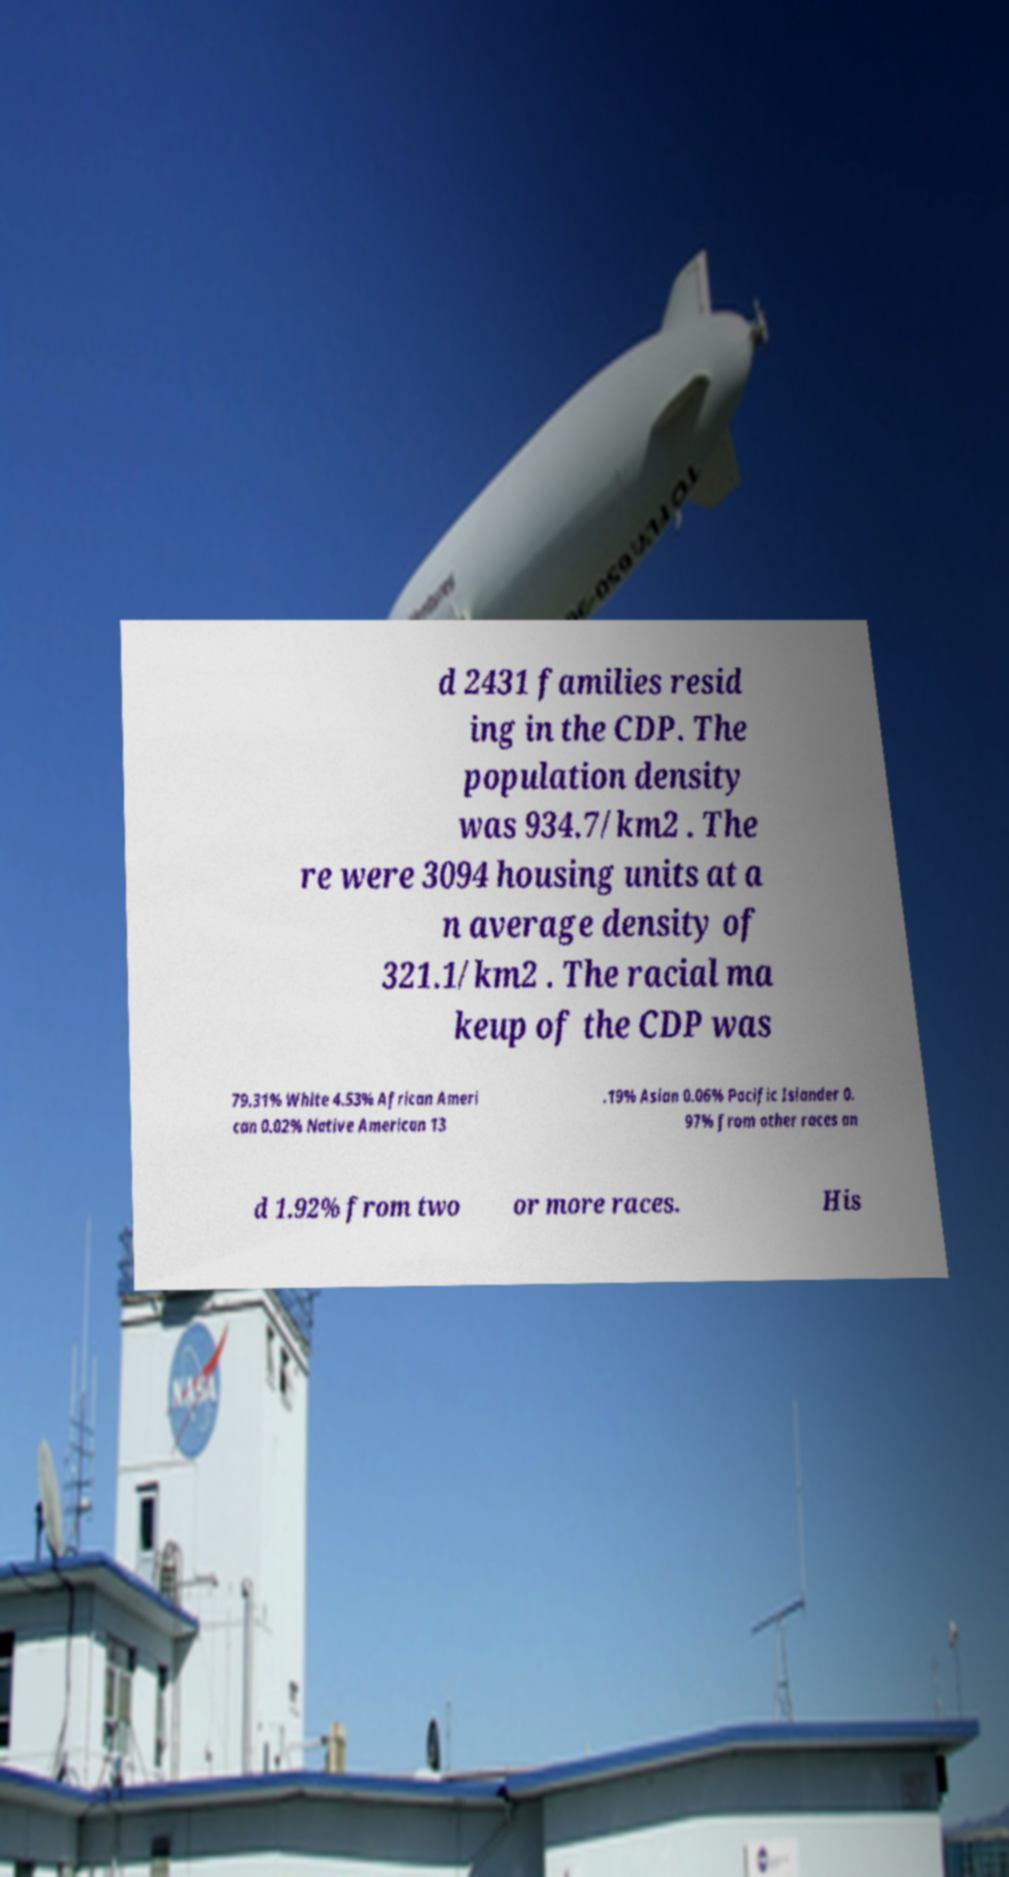What messages or text are displayed in this image? I need them in a readable, typed format. d 2431 families resid ing in the CDP. The population density was 934.7/km2 . The re were 3094 housing units at a n average density of 321.1/km2 . The racial ma keup of the CDP was 79.31% White 4.53% African Ameri can 0.02% Native American 13 .19% Asian 0.06% Pacific Islander 0. 97% from other races an d 1.92% from two or more races. His 